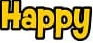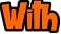Transcribe the words shown in these images in order, separated by a semicolon. Happy; With 